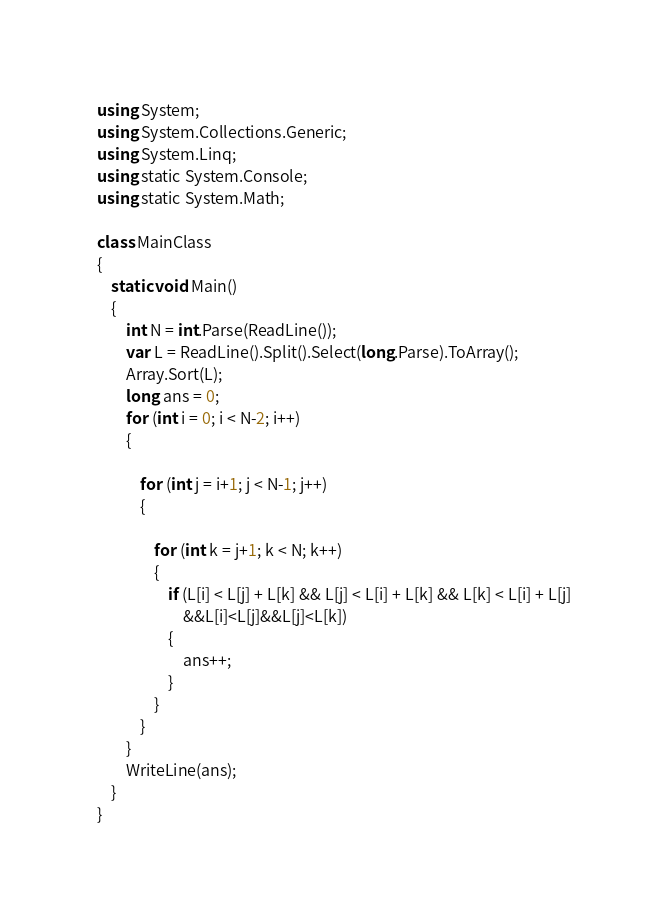Convert code to text. <code><loc_0><loc_0><loc_500><loc_500><_C#_>using System;
using System.Collections.Generic;
using System.Linq;
using static System.Console;
using static System.Math;

class MainClass
{
    static void Main()
    {
        int N = int.Parse(ReadLine());
        var L = ReadLine().Split().Select(long.Parse).ToArray();
        Array.Sort(L);
        long ans = 0;
        for (int i = 0; i < N-2; i++)
        {
            
            for (int j = i+1; j < N-1; j++)
            {
                
                for (int k = j+1; k < N; k++)
                {
                    if (L[i] < L[j] + L[k] && L[j] < L[i] + L[k] && L[k] < L[i] + L[j]
                        &&L[i]<L[j]&&L[j]<L[k])
                    {
                        ans++;
                    }
                }
            }
        }
        WriteLine(ans);
    }
}
</code> 